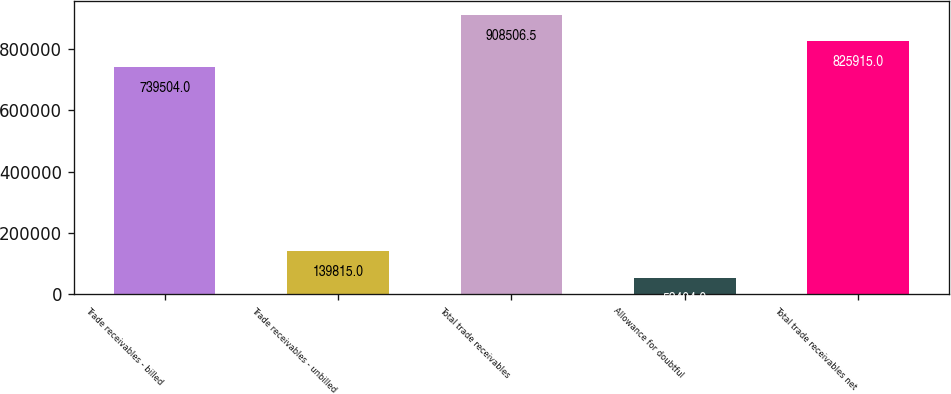<chart> <loc_0><loc_0><loc_500><loc_500><bar_chart><fcel>Trade receivables - billed<fcel>Trade receivables - unbilled<fcel>Total trade receivables<fcel>Allowance for doubtful<fcel>Total trade receivables net<nl><fcel>739504<fcel>139815<fcel>908506<fcel>53404<fcel>825915<nl></chart> 